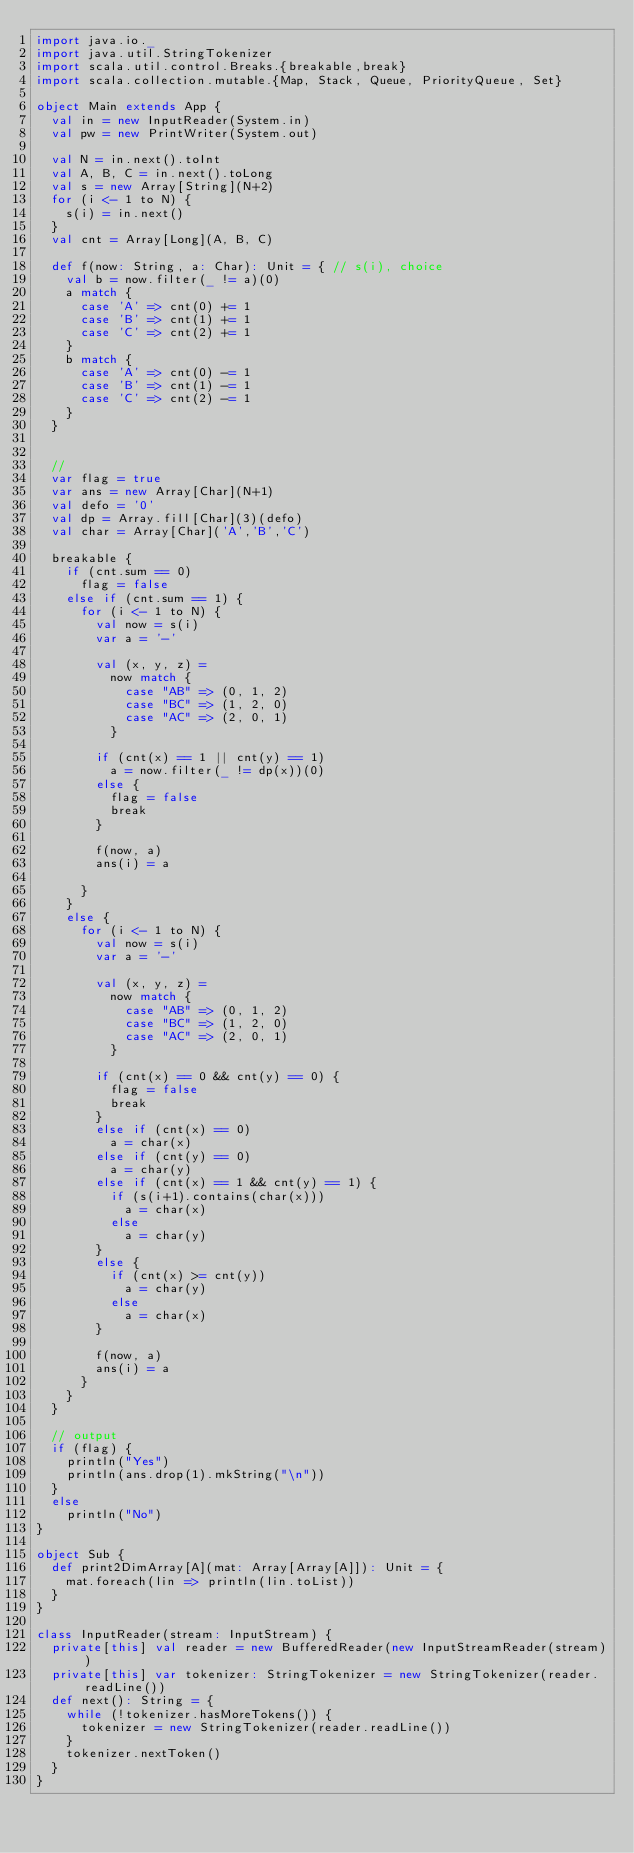<code> <loc_0><loc_0><loc_500><loc_500><_Scala_>import java.io._
import java.util.StringTokenizer
import scala.util.control.Breaks.{breakable,break}
import scala.collection.mutable.{Map, Stack, Queue, PriorityQueue, Set}

object Main extends App {
  val in = new InputReader(System.in)
  val pw = new PrintWriter(System.out)

  val N = in.next().toInt
  val A, B, C = in.next().toLong
  val s = new Array[String](N+2)
  for (i <- 1 to N) {
    s(i) = in.next()
  }
  val cnt = Array[Long](A, B, C)

  def f(now: String, a: Char): Unit = { // s(i), choice
    val b = now.filter(_ != a)(0)
    a match {
      case 'A' => cnt(0) += 1
      case 'B' => cnt(1) += 1
      case 'C' => cnt(2) += 1
    }
    b match {
      case 'A' => cnt(0) -= 1
      case 'B' => cnt(1) -= 1
      case 'C' => cnt(2) -= 1
    }
  }


  //
  var flag = true
  var ans = new Array[Char](N+1)
  val defo = '0'
  val dp = Array.fill[Char](3)(defo)
  val char = Array[Char]('A','B','C')

  breakable {
    if (cnt.sum == 0)
      flag = false
    else if (cnt.sum == 1) {
      for (i <- 1 to N) {
        val now = s(i)
        var a = '-'

        val (x, y, z) =
          now match {
            case "AB" => (0, 1, 2)
            case "BC" => (1, 2, 0)
            case "AC" => (2, 0, 1)
          }

        if (cnt(x) == 1 || cnt(y) == 1)
          a = now.filter(_ != dp(x))(0)
        else {
          flag = false
          break
        }

        f(now, a)
        ans(i) = a

      }
    }
    else {
      for (i <- 1 to N) {
        val now = s(i)
        var a = '-'

        val (x, y, z) =
          now match {
            case "AB" => (0, 1, 2)
            case "BC" => (1, 2, 0)
            case "AC" => (2, 0, 1)
          }

        if (cnt(x) == 0 && cnt(y) == 0) {
          flag = false
          break
        }
        else if (cnt(x) == 0)
          a = char(x)
        else if (cnt(y) == 0)
          a = char(y)
        else if (cnt(x) == 1 && cnt(y) == 1) {
          if (s(i+1).contains(char(x)))
            a = char(x)
          else
            a = char(y)
        }
        else {
          if (cnt(x) >= cnt(y))
            a = char(y)
          else
            a = char(x)
        }

        f(now, a)
        ans(i) = a
      }
    }
  }

  // output
  if (flag) {
    println("Yes")
    println(ans.drop(1).mkString("\n"))
  }
  else
    println("No")
}

object Sub {
  def print2DimArray[A](mat: Array[Array[A]]): Unit = {
    mat.foreach(lin => println(lin.toList))
  }
}

class InputReader(stream: InputStream) {
  private[this] val reader = new BufferedReader(new InputStreamReader(stream))
  private[this] var tokenizer: StringTokenizer = new StringTokenizer(reader.readLine())
  def next(): String = {
    while (!tokenizer.hasMoreTokens()) {
      tokenizer = new StringTokenizer(reader.readLine())
    }
    tokenizer.nextToken()
  }
}
</code> 